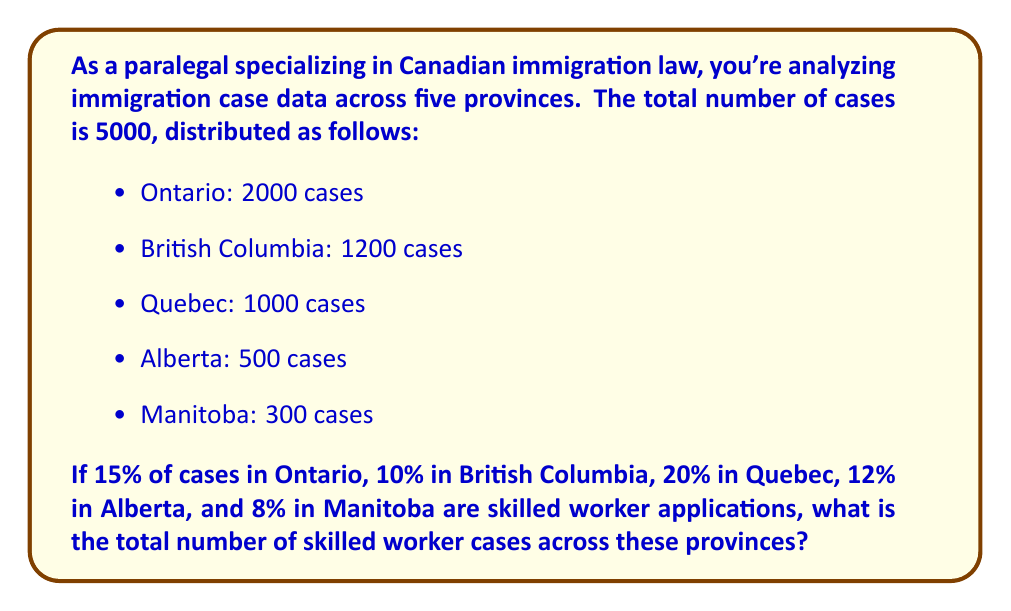Provide a solution to this math problem. To solve this problem, we need to calculate the number of skilled worker cases for each province and then sum them up. Let's break it down step by step:

1. Ontario:
   $2000 \times 15\% = 2000 \times 0.15 = 300$ cases

2. British Columbia:
   $1200 \times 10\% = 1200 \times 0.10 = 120$ cases

3. Quebec:
   $1000 \times 20\% = 1000 \times 0.20 = 200$ cases

4. Alberta:
   $500 \times 12\% = 500 \times 0.12 = 60$ cases

5. Manitoba:
   $300 \times 8\% = 300 \times 0.08 = 24$ cases

Now, we sum up all these cases:

$$ \text{Total skilled worker cases} = 300 + 120 + 200 + 60 + 24 = 704 $$
Answer: The total number of skilled worker cases across the five provinces is 704. 